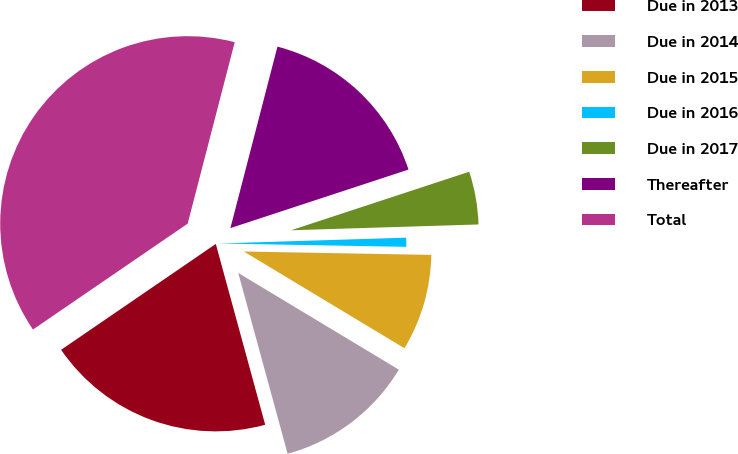Convert chart. <chart><loc_0><loc_0><loc_500><loc_500><pie_chart><fcel>Due in 2013<fcel>Due in 2014<fcel>Due in 2015<fcel>Due in 2016<fcel>Due in 2017<fcel>Thereafter<fcel>Total<nl><fcel>19.69%<fcel>12.13%<fcel>8.34%<fcel>0.78%<fcel>4.56%<fcel>15.91%<fcel>38.59%<nl></chart> 